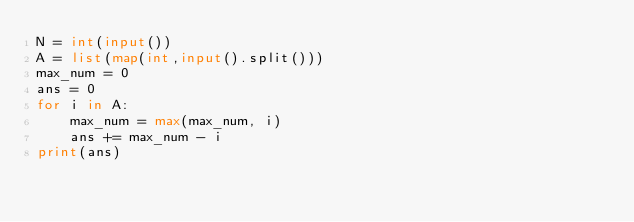Convert code to text. <code><loc_0><loc_0><loc_500><loc_500><_Python_>N = int(input())
A = list(map(int,input().split()))
max_num = 0
ans = 0
for i in A:
    max_num = max(max_num, i)
    ans += max_num - i
print(ans)</code> 